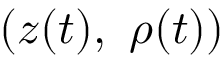<formula> <loc_0><loc_0><loc_500><loc_500>( z ( t ) , \ \rho ( t ) )</formula> 